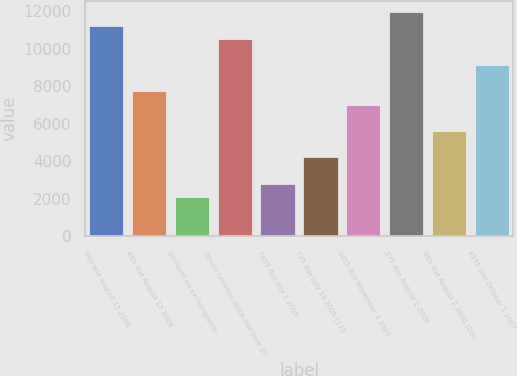<chart> <loc_0><loc_0><loc_500><loc_500><bar_chart><fcel>490 due August 15 2008<fcel>495 due August 15 2008<fcel>Discount on exchangeable<fcel>Devon common stock due June 27<fcel>7625 due July 1 2005<fcel>725 due July 18 2005 (175<fcel>1025 due November 1 2005<fcel>275 due August 1 2006<fcel>655 due August 2 2006 (200<fcel>4375 due October 1 2007<nl><fcel>11247.8<fcel>7733.8<fcel>2111.4<fcel>10545<fcel>2814.2<fcel>4219.8<fcel>7031<fcel>11950.6<fcel>5625.4<fcel>9139.4<nl></chart> 